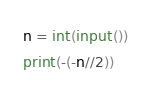<code> <loc_0><loc_0><loc_500><loc_500><_Python_>n = int(input())
print(-(-n//2))
</code> 